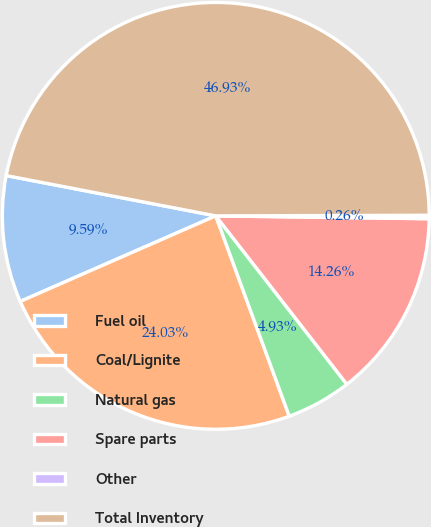Convert chart to OTSL. <chart><loc_0><loc_0><loc_500><loc_500><pie_chart><fcel>Fuel oil<fcel>Coal/Lignite<fcel>Natural gas<fcel>Spare parts<fcel>Other<fcel>Total Inventory<nl><fcel>9.59%<fcel>24.03%<fcel>4.93%<fcel>14.26%<fcel>0.26%<fcel>46.93%<nl></chart> 